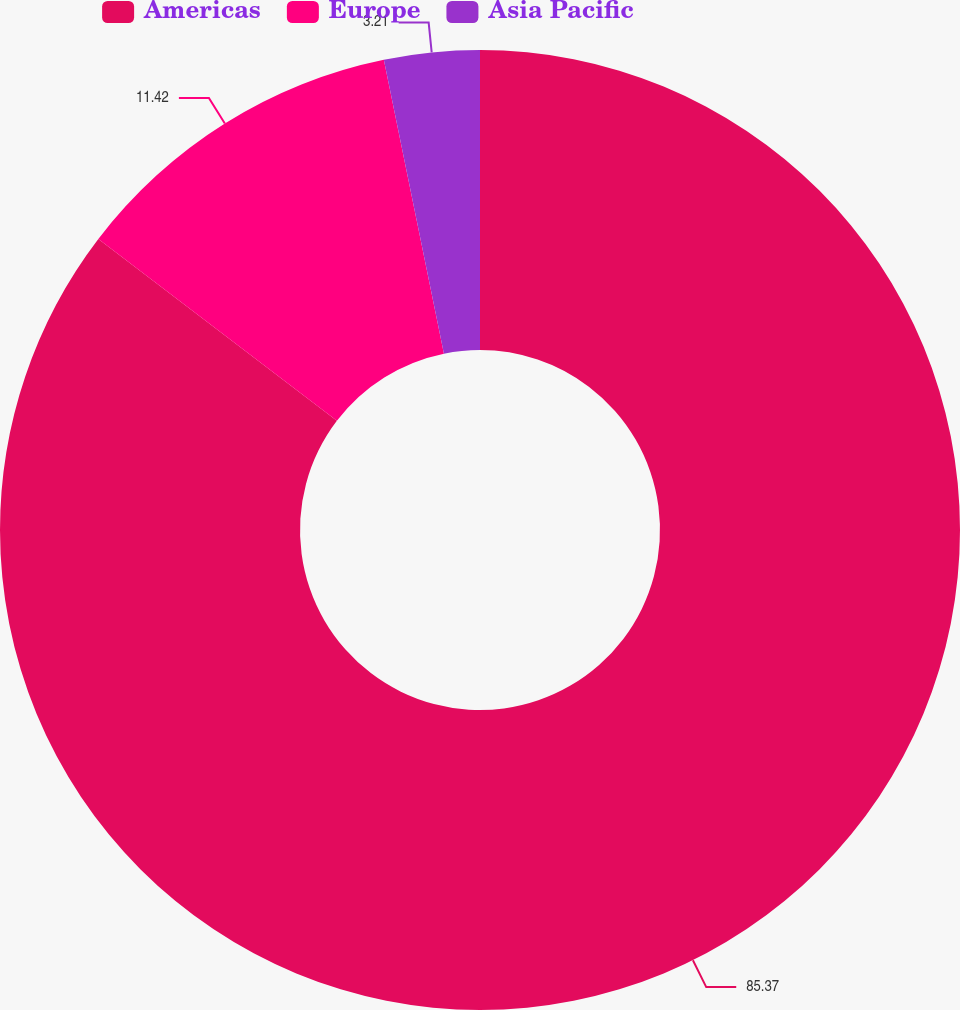Convert chart to OTSL. <chart><loc_0><loc_0><loc_500><loc_500><pie_chart><fcel>Americas<fcel>Europe<fcel>Asia Pacific<nl><fcel>85.37%<fcel>11.42%<fcel>3.21%<nl></chart> 